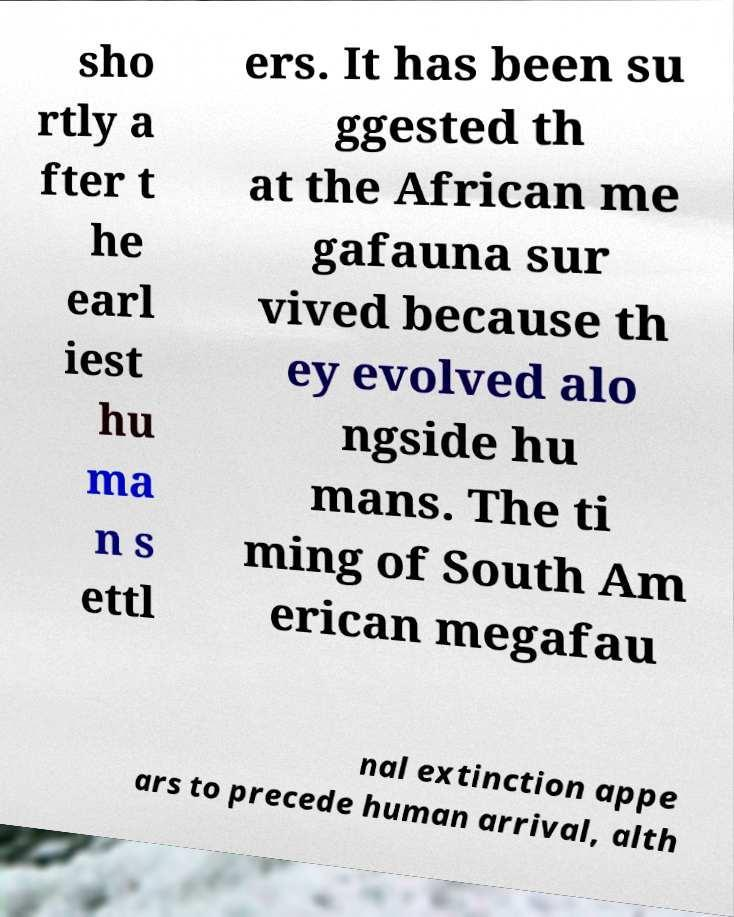Please read and relay the text visible in this image. What does it say? sho rtly a fter t he earl iest hu ma n s ettl ers. It has been su ggested th at the African me gafauna sur vived because th ey evolved alo ngside hu mans. The ti ming of South Am erican megafau nal extinction appe ars to precede human arrival, alth 